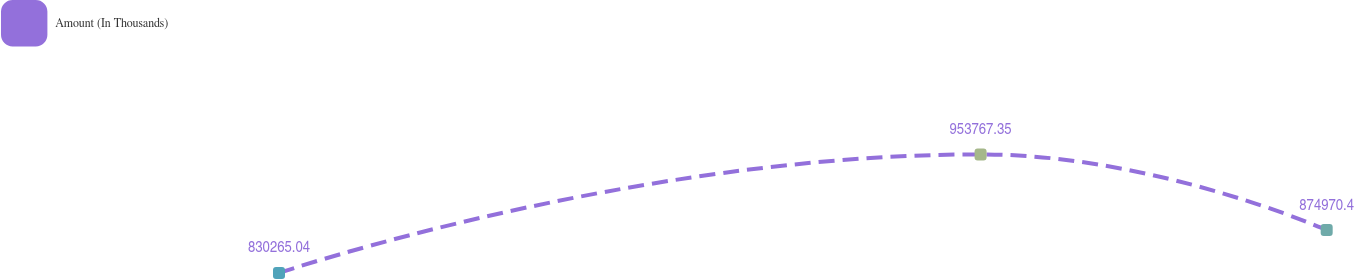<chart> <loc_0><loc_0><loc_500><loc_500><line_chart><ecel><fcel>Amount (In Thousands)<nl><fcel>1707.51<fcel>830265<nl><fcel>2020.31<fcel>953767<nl><fcel>2174.62<fcel>874970<nl><fcel>2226.41<fcel>1.1377e+06<nl><fcel>2278.2<fcel>1.27732e+06<nl></chart> 